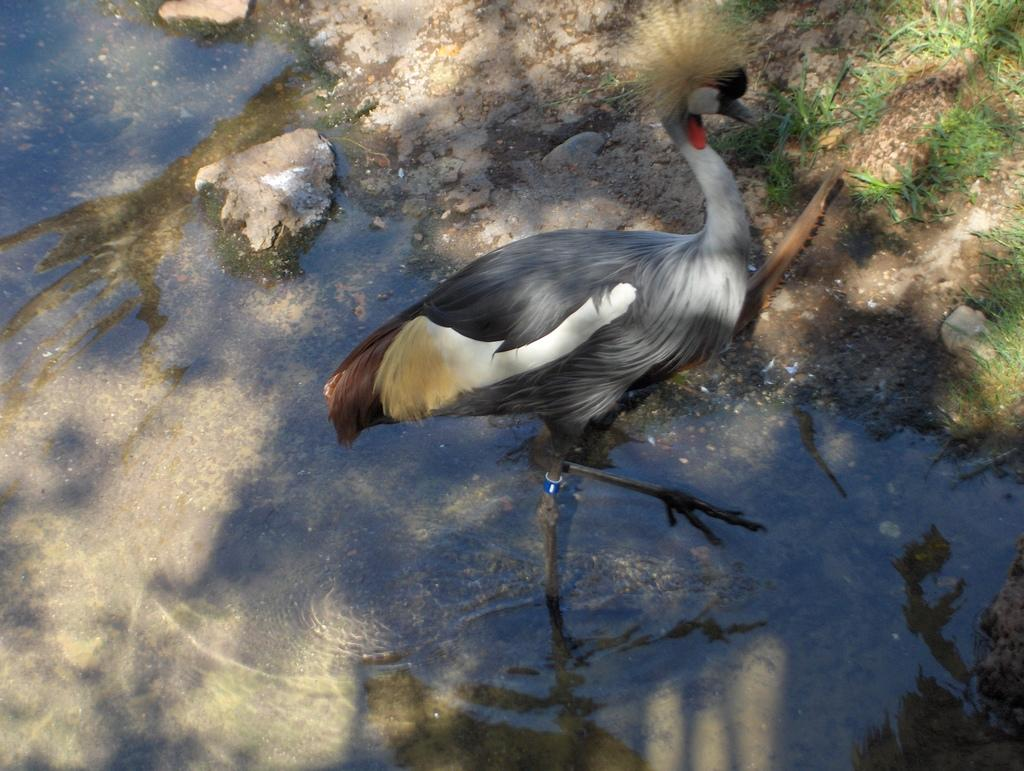What type of animal can be seen in the water in the image? There is a bird in the water in the image. What can be seen in the background of the image? There are rocks visible in the background of the image. What type of vegetation is present in the image? There is grass present in the image. What type of music can be heard playing in the background of the image? There is no music present in the image; it is a still image of a bird in the water. 